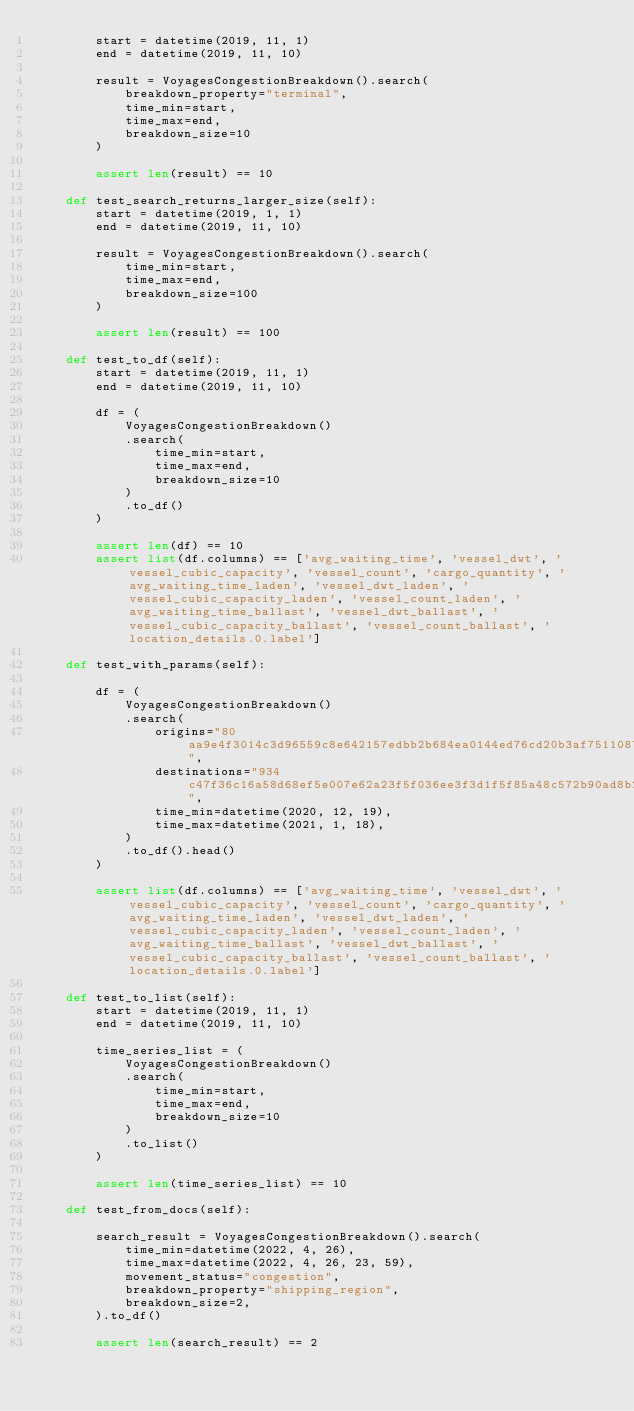Convert code to text. <code><loc_0><loc_0><loc_500><loc_500><_Python_>        start = datetime(2019, 11, 1)
        end = datetime(2019, 11, 10)

        result = VoyagesCongestionBreakdown().search(
            breakdown_property="terminal",
            time_min=start,
            time_max=end,
            breakdown_size=10
        )

        assert len(result) == 10

    def test_search_returns_larger_size(self):
        start = datetime(2019, 1, 1)
        end = datetime(2019, 11, 10)

        result = VoyagesCongestionBreakdown().search(
            time_min=start,
            time_max=end,
            breakdown_size=100
        )

        assert len(result) == 100

    def test_to_df(self):
        start = datetime(2019, 11, 1)
        end = datetime(2019, 11, 10)

        df = (
            VoyagesCongestionBreakdown()
            .search(
                time_min=start,
                time_max=end,
                breakdown_size=10
            )
            .to_df()
        )

        assert len(df) == 10
        assert list(df.columns) == ['avg_waiting_time', 'vessel_dwt', 'vessel_cubic_capacity', 'vessel_count', 'cargo_quantity', 'avg_waiting_time_laden', 'vessel_dwt_laden', 'vessel_cubic_capacity_laden', 'vessel_count_laden', 'avg_waiting_time_ballast', 'vessel_dwt_ballast', 'vessel_cubic_capacity_ballast', 'vessel_count_ballast', 'location_details.0.label']

    def test_with_params(self):

        df = (
            VoyagesCongestionBreakdown()
            .search(
                origins="80aa9e4f3014c3d96559c8e642157edbb2b684ea0144ed76cd20b3af75110877",
                destinations="934c47f36c16a58d68ef5e007e62a23f5f036ee3f3d1f5f85a48c572b90ad8b2",
                time_min=datetime(2020, 12, 19),
                time_max=datetime(2021, 1, 18),
            )
            .to_df().head()
        )

        assert list(df.columns) == ['avg_waiting_time', 'vessel_dwt', 'vessel_cubic_capacity', 'vessel_count', 'cargo_quantity', 'avg_waiting_time_laden', 'vessel_dwt_laden', 'vessel_cubic_capacity_laden', 'vessel_count_laden', 'avg_waiting_time_ballast', 'vessel_dwt_ballast', 'vessel_cubic_capacity_ballast', 'vessel_count_ballast', 'location_details.0.label']

    def test_to_list(self):
        start = datetime(2019, 11, 1)
        end = datetime(2019, 11, 10)

        time_series_list = (
            VoyagesCongestionBreakdown()
            .search(
                time_min=start,
                time_max=end,
                breakdown_size=10
            )
            .to_list()
        )

        assert len(time_series_list) == 10

    def test_from_docs(self):

        search_result = VoyagesCongestionBreakdown().search(
            time_min=datetime(2022, 4, 26),
            time_max=datetime(2022, 4, 26, 23, 59),
            movement_status="congestion",
            breakdown_property="shipping_region",
            breakdown_size=2,
        ).to_df()

        assert len(search_result) == 2
</code> 